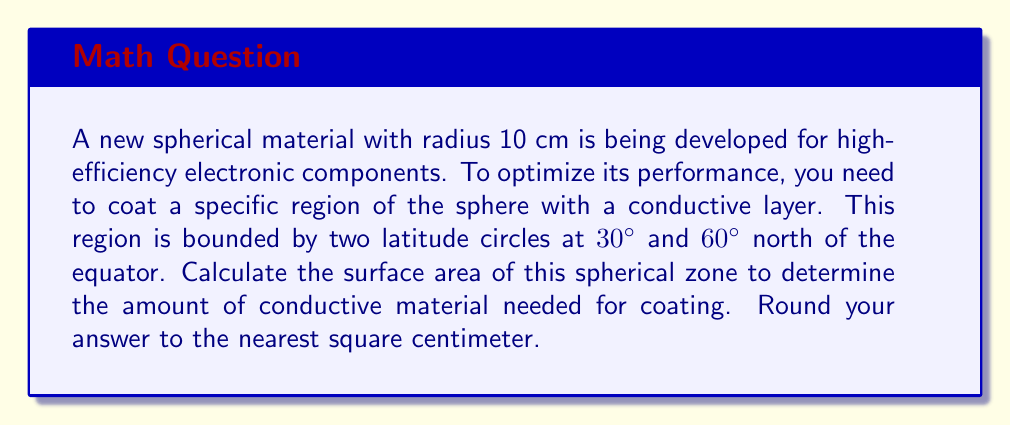Give your solution to this math problem. To solve this problem, we'll use the formula for the surface area of a spherical zone:

$$A = 2\pi rh$$

where $A$ is the surface area, $r$ is the radius of the sphere, and $h$ is the height of the zone.

Step 1: Calculate the height of the zone.
The height is the difference between the y-coordinates of the two latitude circles:
$$h = r(\sin 60° - \sin 30°)$$
$$h = 10(\sin 60° - \sin 30°)$$
$$h = 10(0.866 - 0.5)$$
$$h = 10(0.366) = 3.66 \text{ cm}$$

Step 2: Apply the surface area formula:
$$A = 2\pi rh$$
$$A = 2\pi(10)(3.66)$$
$$A = 230.05 \text{ cm}^2$$

Step 3: Round to the nearest square centimeter:
$$A \approx 230 \text{ cm}^2$$

[asy]
import geometry;

size(200);
draw(circle((0,0),10));
draw((-10,0)--(10,0),dashed);
draw((-8.66,5)--(8.66,5));
draw((-5,8.66)--(5,8.66));
label("30°", (8,2.5));
label("60°", (4,7.5));
label("Equator", (8,-1));
[/asy]
Answer: 230 cm² 